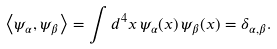<formula> <loc_0><loc_0><loc_500><loc_500>\left < \psi _ { \alpha } , \psi _ { \beta } \right > = \int d ^ { 4 } x \, \psi _ { \alpha } ( x ) \, \psi _ { \beta } ( x ) = \delta _ { \alpha , \beta } .</formula> 